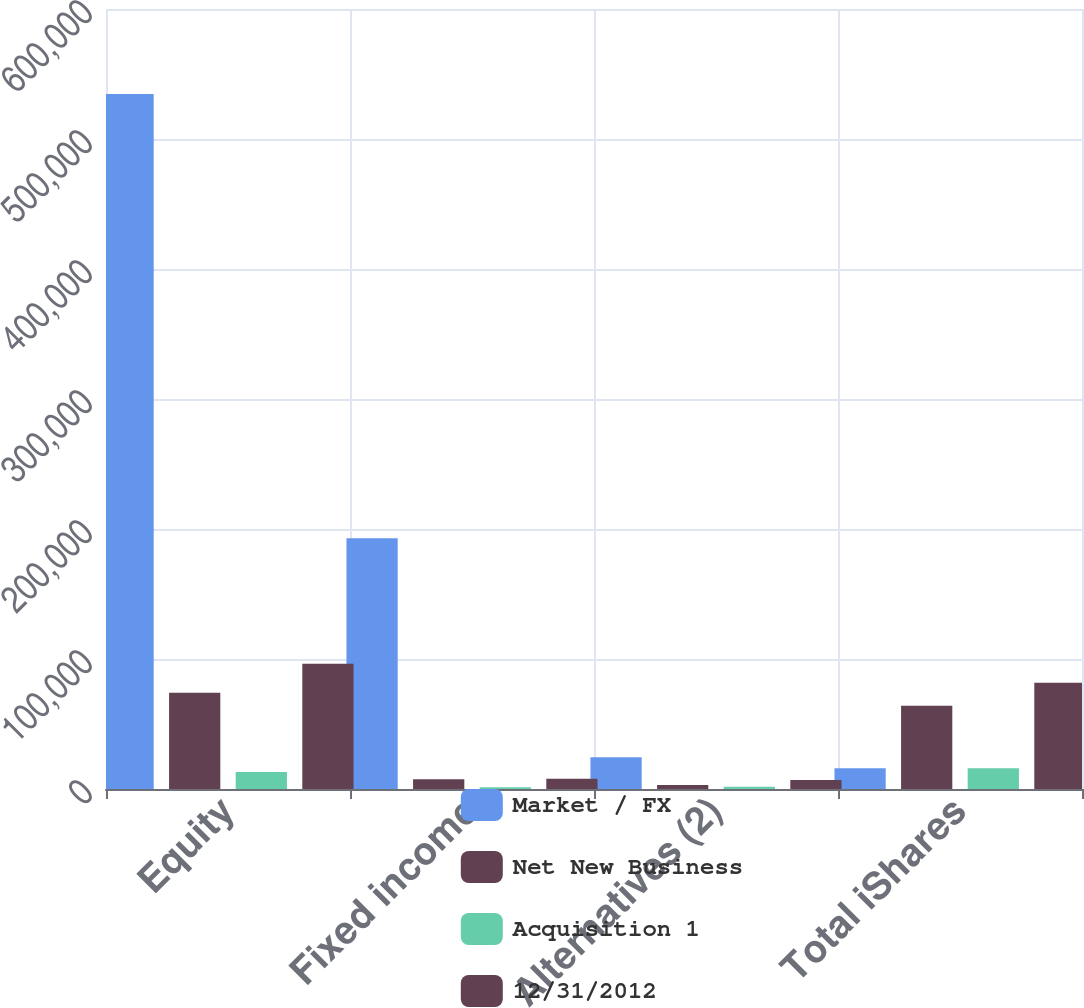Convert chart to OTSL. <chart><loc_0><loc_0><loc_500><loc_500><stacked_bar_chart><ecel><fcel>Equity<fcel>Fixed income<fcel>Alternatives (2)<fcel>Total iShares<nl><fcel>Market / FX<fcel>534648<fcel>192852<fcel>24337<fcel>15960<nl><fcel>Net New Business<fcel>74119<fcel>7450<fcel>3053<fcel>63971<nl><fcel>Acquisition 1<fcel>13021<fcel>1294<fcel>1645<fcel>15960<nl><fcel>12/31/2012<fcel>96347<fcel>7861<fcel>6837<fcel>81735<nl></chart> 